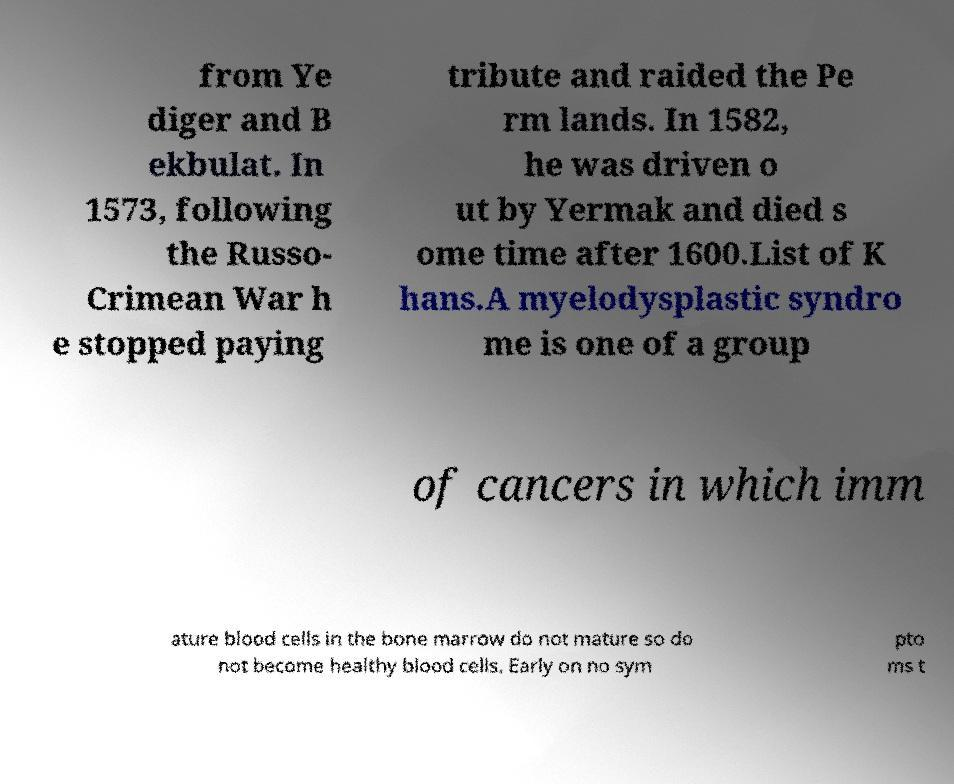For documentation purposes, I need the text within this image transcribed. Could you provide that? from Ye diger and B ekbulat. In 1573, following the Russo- Crimean War h e stopped paying tribute and raided the Pe rm lands. In 1582, he was driven o ut by Yermak and died s ome time after 1600.List of K hans.A myelodysplastic syndro me is one of a group of cancers in which imm ature blood cells in the bone marrow do not mature so do not become healthy blood cells. Early on no sym pto ms t 